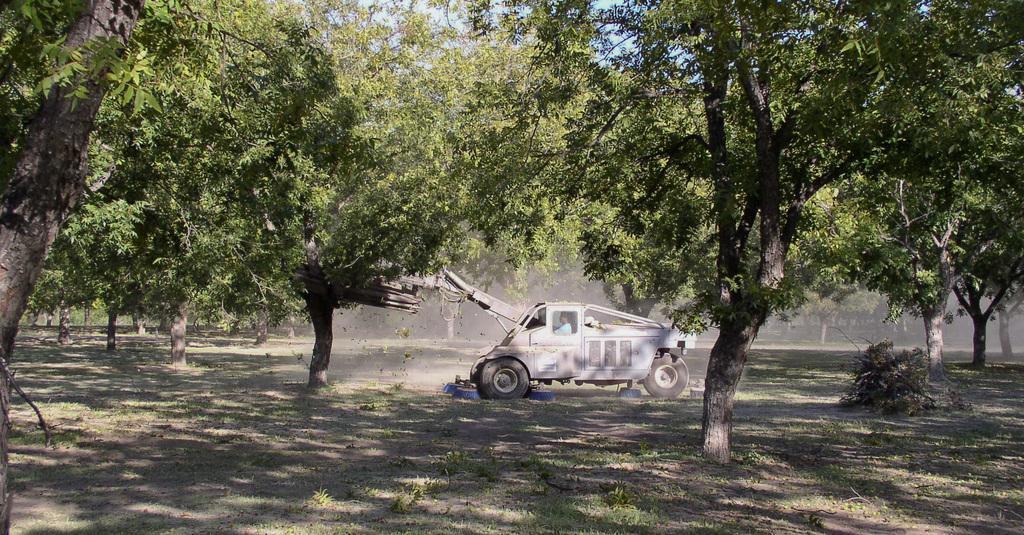Can you describe this image briefly? In the center of the image we can see a man is driving a vehicle. In the background of the image we can see the trees. At the bottom of the image we can see the ground, plants and dry leaves. At the top of the image we can see the sky. 